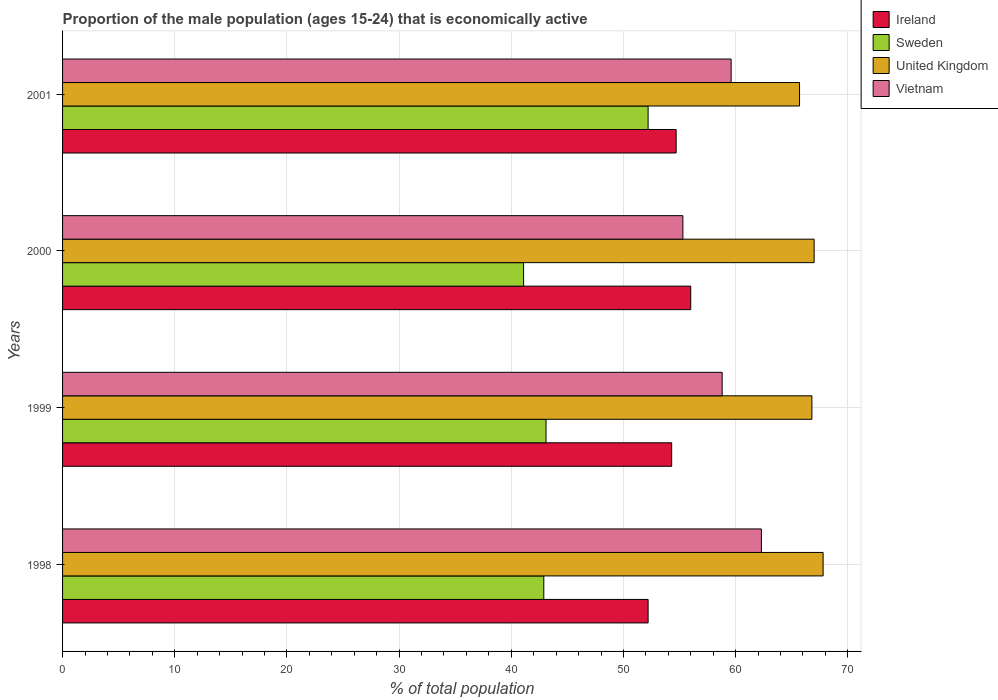How many groups of bars are there?
Your answer should be very brief. 4. Are the number of bars on each tick of the Y-axis equal?
Offer a very short reply. Yes. How many bars are there on the 4th tick from the top?
Make the answer very short. 4. In how many cases, is the number of bars for a given year not equal to the number of legend labels?
Ensure brevity in your answer.  0. What is the proportion of the male population that is economically active in Vietnam in 2001?
Give a very brief answer. 59.6. Across all years, what is the maximum proportion of the male population that is economically active in Vietnam?
Provide a short and direct response. 62.3. Across all years, what is the minimum proportion of the male population that is economically active in Ireland?
Offer a very short reply. 52.2. In which year was the proportion of the male population that is economically active in Ireland maximum?
Keep it short and to the point. 2000. In which year was the proportion of the male population that is economically active in Sweden minimum?
Your response must be concise. 2000. What is the total proportion of the male population that is economically active in Sweden in the graph?
Make the answer very short. 179.3. What is the difference between the proportion of the male population that is economically active in Sweden in 1999 and that in 2000?
Your answer should be very brief. 2. What is the difference between the proportion of the male population that is economically active in United Kingdom in 1999 and the proportion of the male population that is economically active in Ireland in 2001?
Your answer should be compact. 12.1. What is the average proportion of the male population that is economically active in United Kingdom per year?
Your answer should be compact. 66.83. In the year 1999, what is the difference between the proportion of the male population that is economically active in Vietnam and proportion of the male population that is economically active in United Kingdom?
Your answer should be compact. -8. In how many years, is the proportion of the male population that is economically active in Ireland greater than 52 %?
Ensure brevity in your answer.  4. What is the ratio of the proportion of the male population that is economically active in Sweden in 1999 to that in 2001?
Your response must be concise. 0.83. Is the proportion of the male population that is economically active in Vietnam in 1998 less than that in 2000?
Keep it short and to the point. No. Is the difference between the proportion of the male population that is economically active in Vietnam in 1998 and 2000 greater than the difference between the proportion of the male population that is economically active in United Kingdom in 1998 and 2000?
Your response must be concise. Yes. What is the difference between the highest and the second highest proportion of the male population that is economically active in Sweden?
Your answer should be compact. 9.1. What does the 1st bar from the top in 1999 represents?
Your answer should be compact. Vietnam. What does the 3rd bar from the bottom in 1999 represents?
Make the answer very short. United Kingdom. Is it the case that in every year, the sum of the proportion of the male population that is economically active in Ireland and proportion of the male population that is economically active in Sweden is greater than the proportion of the male population that is economically active in United Kingdom?
Keep it short and to the point. Yes. How many bars are there?
Keep it short and to the point. 16. Are the values on the major ticks of X-axis written in scientific E-notation?
Give a very brief answer. No. Does the graph contain any zero values?
Your response must be concise. No. What is the title of the graph?
Ensure brevity in your answer.  Proportion of the male population (ages 15-24) that is economically active. Does "Ireland" appear as one of the legend labels in the graph?
Offer a very short reply. Yes. What is the label or title of the X-axis?
Your answer should be very brief. % of total population. What is the % of total population in Ireland in 1998?
Provide a succinct answer. 52.2. What is the % of total population of Sweden in 1998?
Offer a terse response. 42.9. What is the % of total population in United Kingdom in 1998?
Give a very brief answer. 67.8. What is the % of total population in Vietnam in 1998?
Keep it short and to the point. 62.3. What is the % of total population of Ireland in 1999?
Provide a short and direct response. 54.3. What is the % of total population in Sweden in 1999?
Offer a very short reply. 43.1. What is the % of total population in United Kingdom in 1999?
Ensure brevity in your answer.  66.8. What is the % of total population in Vietnam in 1999?
Your answer should be compact. 58.8. What is the % of total population in Ireland in 2000?
Provide a short and direct response. 56. What is the % of total population of Sweden in 2000?
Offer a terse response. 41.1. What is the % of total population of Vietnam in 2000?
Provide a short and direct response. 55.3. What is the % of total population of Ireland in 2001?
Offer a very short reply. 54.7. What is the % of total population in Sweden in 2001?
Make the answer very short. 52.2. What is the % of total population of United Kingdom in 2001?
Keep it short and to the point. 65.7. What is the % of total population of Vietnam in 2001?
Make the answer very short. 59.6. Across all years, what is the maximum % of total population of Sweden?
Make the answer very short. 52.2. Across all years, what is the maximum % of total population in United Kingdom?
Offer a very short reply. 67.8. Across all years, what is the maximum % of total population in Vietnam?
Your response must be concise. 62.3. Across all years, what is the minimum % of total population in Ireland?
Make the answer very short. 52.2. Across all years, what is the minimum % of total population in Sweden?
Offer a terse response. 41.1. Across all years, what is the minimum % of total population in United Kingdom?
Offer a very short reply. 65.7. Across all years, what is the minimum % of total population of Vietnam?
Ensure brevity in your answer.  55.3. What is the total % of total population in Ireland in the graph?
Your response must be concise. 217.2. What is the total % of total population in Sweden in the graph?
Give a very brief answer. 179.3. What is the total % of total population of United Kingdom in the graph?
Provide a succinct answer. 267.3. What is the total % of total population in Vietnam in the graph?
Provide a succinct answer. 236. What is the difference between the % of total population of Ireland in 1998 and that in 1999?
Provide a short and direct response. -2.1. What is the difference between the % of total population of Sweden in 1998 and that in 1999?
Provide a short and direct response. -0.2. What is the difference between the % of total population of United Kingdom in 1998 and that in 1999?
Ensure brevity in your answer.  1. What is the difference between the % of total population of Ireland in 1998 and that in 2000?
Your answer should be compact. -3.8. What is the difference between the % of total population in United Kingdom in 1998 and that in 2000?
Keep it short and to the point. 0.8. What is the difference between the % of total population of Sweden in 1998 and that in 2001?
Provide a succinct answer. -9.3. What is the difference between the % of total population of United Kingdom in 1998 and that in 2001?
Your answer should be very brief. 2.1. What is the difference between the % of total population of Vietnam in 1998 and that in 2001?
Provide a succinct answer. 2.7. What is the difference between the % of total population of Sweden in 1999 and that in 2000?
Ensure brevity in your answer.  2. What is the difference between the % of total population of United Kingdom in 1999 and that in 2000?
Ensure brevity in your answer.  -0.2. What is the difference between the % of total population of Vietnam in 1999 and that in 2000?
Keep it short and to the point. 3.5. What is the difference between the % of total population in Ireland in 1999 and that in 2001?
Provide a succinct answer. -0.4. What is the difference between the % of total population in Sweden in 1999 and that in 2001?
Provide a succinct answer. -9.1. What is the difference between the % of total population of United Kingdom in 1999 and that in 2001?
Provide a short and direct response. 1.1. What is the difference between the % of total population in Vietnam in 1999 and that in 2001?
Make the answer very short. -0.8. What is the difference between the % of total population of Ireland in 2000 and that in 2001?
Give a very brief answer. 1.3. What is the difference between the % of total population of Ireland in 1998 and the % of total population of Sweden in 1999?
Provide a succinct answer. 9.1. What is the difference between the % of total population of Ireland in 1998 and the % of total population of United Kingdom in 1999?
Your response must be concise. -14.6. What is the difference between the % of total population in Ireland in 1998 and the % of total population in Vietnam in 1999?
Make the answer very short. -6.6. What is the difference between the % of total population of Sweden in 1998 and the % of total population of United Kingdom in 1999?
Your response must be concise. -23.9. What is the difference between the % of total population in Sweden in 1998 and the % of total population in Vietnam in 1999?
Give a very brief answer. -15.9. What is the difference between the % of total population in Ireland in 1998 and the % of total population in United Kingdom in 2000?
Ensure brevity in your answer.  -14.8. What is the difference between the % of total population of Ireland in 1998 and the % of total population of Vietnam in 2000?
Provide a short and direct response. -3.1. What is the difference between the % of total population in Sweden in 1998 and the % of total population in United Kingdom in 2000?
Your answer should be compact. -24.1. What is the difference between the % of total population of Sweden in 1998 and the % of total population of Vietnam in 2000?
Your response must be concise. -12.4. What is the difference between the % of total population of Ireland in 1998 and the % of total population of Vietnam in 2001?
Give a very brief answer. -7.4. What is the difference between the % of total population of Sweden in 1998 and the % of total population of United Kingdom in 2001?
Your answer should be compact. -22.8. What is the difference between the % of total population in Sweden in 1998 and the % of total population in Vietnam in 2001?
Your answer should be very brief. -16.7. What is the difference between the % of total population in United Kingdom in 1998 and the % of total population in Vietnam in 2001?
Your answer should be very brief. 8.2. What is the difference between the % of total population in Ireland in 1999 and the % of total population in Vietnam in 2000?
Offer a terse response. -1. What is the difference between the % of total population of Sweden in 1999 and the % of total population of United Kingdom in 2000?
Keep it short and to the point. -23.9. What is the difference between the % of total population of United Kingdom in 1999 and the % of total population of Vietnam in 2000?
Provide a short and direct response. 11.5. What is the difference between the % of total population in Ireland in 1999 and the % of total population in Sweden in 2001?
Provide a succinct answer. 2.1. What is the difference between the % of total population in Ireland in 1999 and the % of total population in United Kingdom in 2001?
Keep it short and to the point. -11.4. What is the difference between the % of total population in Sweden in 1999 and the % of total population in United Kingdom in 2001?
Provide a succinct answer. -22.6. What is the difference between the % of total population in Sweden in 1999 and the % of total population in Vietnam in 2001?
Your response must be concise. -16.5. What is the difference between the % of total population of United Kingdom in 1999 and the % of total population of Vietnam in 2001?
Offer a terse response. 7.2. What is the difference between the % of total population in Sweden in 2000 and the % of total population in United Kingdom in 2001?
Your answer should be very brief. -24.6. What is the difference between the % of total population of Sweden in 2000 and the % of total population of Vietnam in 2001?
Ensure brevity in your answer.  -18.5. What is the average % of total population in Ireland per year?
Keep it short and to the point. 54.3. What is the average % of total population of Sweden per year?
Provide a short and direct response. 44.83. What is the average % of total population in United Kingdom per year?
Make the answer very short. 66.83. What is the average % of total population of Vietnam per year?
Provide a succinct answer. 59. In the year 1998, what is the difference between the % of total population of Ireland and % of total population of United Kingdom?
Keep it short and to the point. -15.6. In the year 1998, what is the difference between the % of total population of Sweden and % of total population of United Kingdom?
Give a very brief answer. -24.9. In the year 1998, what is the difference between the % of total population of Sweden and % of total population of Vietnam?
Your response must be concise. -19.4. In the year 1999, what is the difference between the % of total population in Ireland and % of total population in Sweden?
Offer a terse response. 11.2. In the year 1999, what is the difference between the % of total population in Sweden and % of total population in United Kingdom?
Make the answer very short. -23.7. In the year 1999, what is the difference between the % of total population of Sweden and % of total population of Vietnam?
Ensure brevity in your answer.  -15.7. In the year 2000, what is the difference between the % of total population in Ireland and % of total population in Sweden?
Your answer should be compact. 14.9. In the year 2000, what is the difference between the % of total population of Sweden and % of total population of United Kingdom?
Make the answer very short. -25.9. In the year 2000, what is the difference between the % of total population of United Kingdom and % of total population of Vietnam?
Offer a terse response. 11.7. In the year 2001, what is the difference between the % of total population of Ireland and % of total population of United Kingdom?
Keep it short and to the point. -11. What is the ratio of the % of total population in Ireland in 1998 to that in 1999?
Give a very brief answer. 0.96. What is the ratio of the % of total population of Sweden in 1998 to that in 1999?
Your answer should be very brief. 1. What is the ratio of the % of total population of United Kingdom in 1998 to that in 1999?
Provide a short and direct response. 1.01. What is the ratio of the % of total population of Vietnam in 1998 to that in 1999?
Your answer should be very brief. 1.06. What is the ratio of the % of total population of Ireland in 1998 to that in 2000?
Your answer should be very brief. 0.93. What is the ratio of the % of total population of Sweden in 1998 to that in 2000?
Your answer should be compact. 1.04. What is the ratio of the % of total population in United Kingdom in 1998 to that in 2000?
Keep it short and to the point. 1.01. What is the ratio of the % of total population of Vietnam in 1998 to that in 2000?
Offer a terse response. 1.13. What is the ratio of the % of total population of Ireland in 1998 to that in 2001?
Provide a succinct answer. 0.95. What is the ratio of the % of total population of Sweden in 1998 to that in 2001?
Give a very brief answer. 0.82. What is the ratio of the % of total population in United Kingdom in 1998 to that in 2001?
Your response must be concise. 1.03. What is the ratio of the % of total population in Vietnam in 1998 to that in 2001?
Your answer should be very brief. 1.05. What is the ratio of the % of total population in Ireland in 1999 to that in 2000?
Ensure brevity in your answer.  0.97. What is the ratio of the % of total population in Sweden in 1999 to that in 2000?
Ensure brevity in your answer.  1.05. What is the ratio of the % of total population of United Kingdom in 1999 to that in 2000?
Ensure brevity in your answer.  1. What is the ratio of the % of total population of Vietnam in 1999 to that in 2000?
Offer a very short reply. 1.06. What is the ratio of the % of total population of Ireland in 1999 to that in 2001?
Offer a terse response. 0.99. What is the ratio of the % of total population in Sweden in 1999 to that in 2001?
Make the answer very short. 0.83. What is the ratio of the % of total population in United Kingdom in 1999 to that in 2001?
Ensure brevity in your answer.  1.02. What is the ratio of the % of total population in Vietnam in 1999 to that in 2001?
Give a very brief answer. 0.99. What is the ratio of the % of total population in Ireland in 2000 to that in 2001?
Your answer should be compact. 1.02. What is the ratio of the % of total population of Sweden in 2000 to that in 2001?
Offer a terse response. 0.79. What is the ratio of the % of total population of United Kingdom in 2000 to that in 2001?
Provide a succinct answer. 1.02. What is the ratio of the % of total population in Vietnam in 2000 to that in 2001?
Your answer should be compact. 0.93. What is the difference between the highest and the second highest % of total population in Ireland?
Give a very brief answer. 1.3. What is the difference between the highest and the second highest % of total population in United Kingdom?
Offer a terse response. 0.8. What is the difference between the highest and the lowest % of total population of Ireland?
Keep it short and to the point. 3.8. What is the difference between the highest and the lowest % of total population in Sweden?
Your answer should be compact. 11.1. What is the difference between the highest and the lowest % of total population of Vietnam?
Provide a succinct answer. 7. 